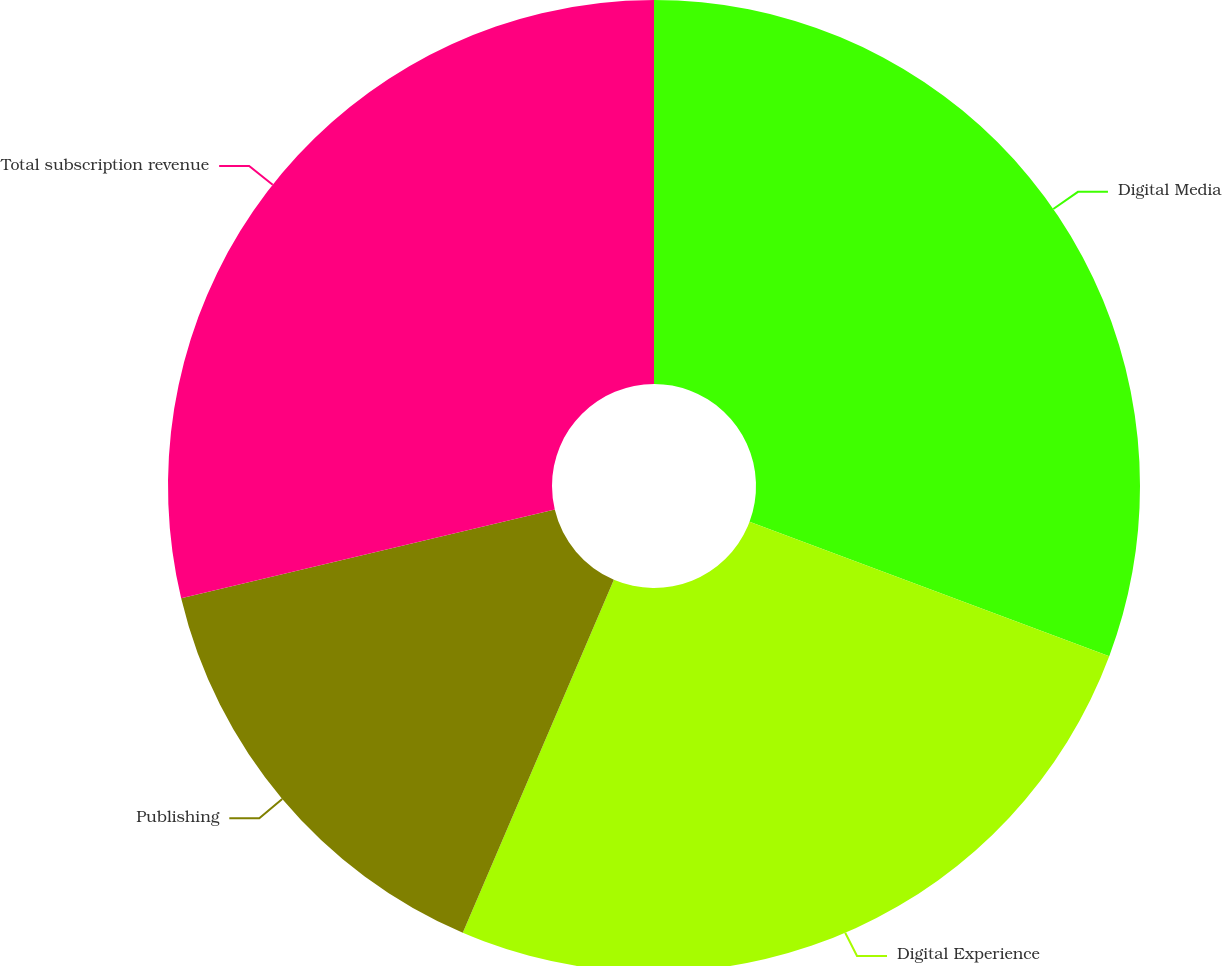<chart> <loc_0><loc_0><loc_500><loc_500><pie_chart><fcel>Digital Media<fcel>Digital Experience<fcel>Publishing<fcel>Total subscription revenue<nl><fcel>30.69%<fcel>25.74%<fcel>14.85%<fcel>28.71%<nl></chart> 